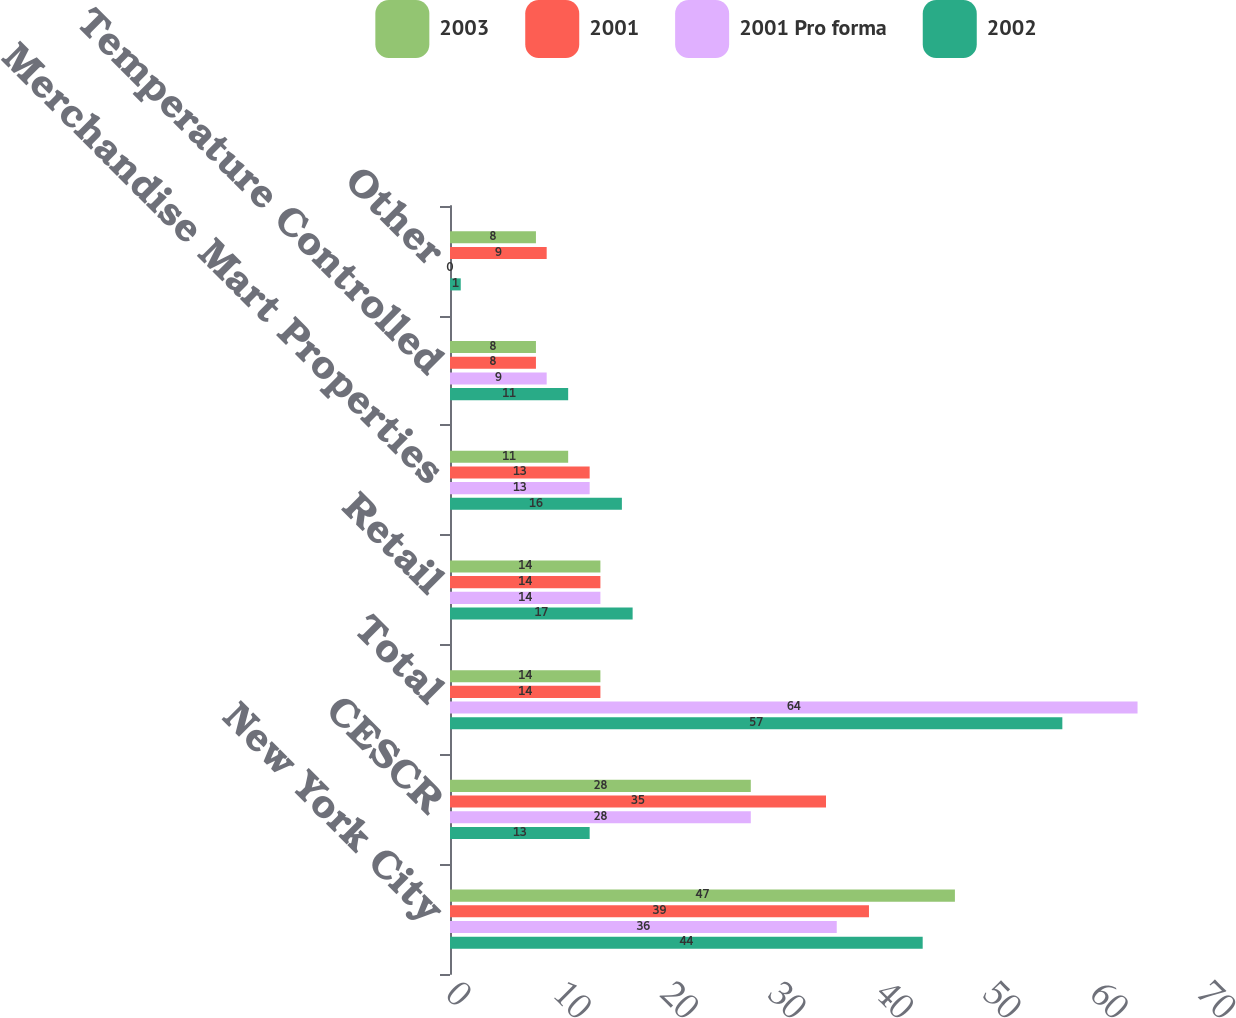Convert chart to OTSL. <chart><loc_0><loc_0><loc_500><loc_500><stacked_bar_chart><ecel><fcel>New York City<fcel>CESCR<fcel>Total<fcel>Retail<fcel>Merchandise Mart Properties<fcel>Temperature Controlled<fcel>Other<nl><fcel>2003<fcel>47<fcel>28<fcel>14<fcel>14<fcel>11<fcel>8<fcel>8<nl><fcel>2001<fcel>39<fcel>35<fcel>14<fcel>14<fcel>13<fcel>8<fcel>9<nl><fcel>2001 Pro forma<fcel>36<fcel>28<fcel>64<fcel>14<fcel>13<fcel>9<fcel>0<nl><fcel>2002<fcel>44<fcel>13<fcel>57<fcel>17<fcel>16<fcel>11<fcel>1<nl></chart> 